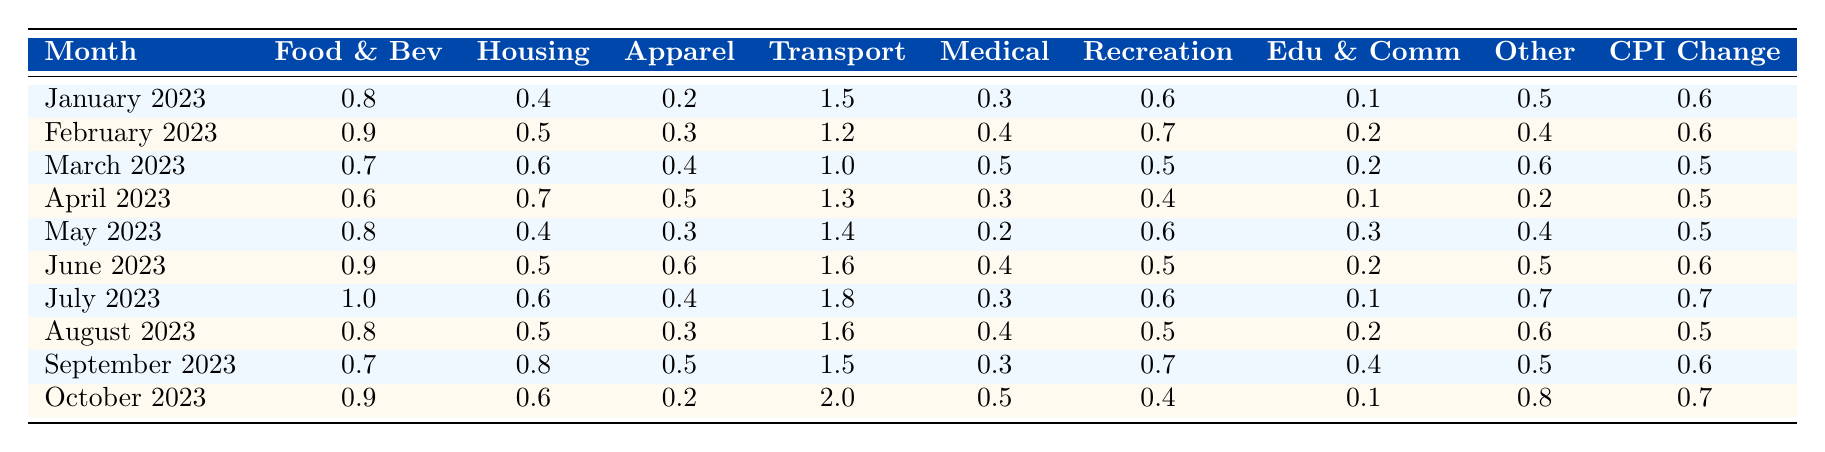What was the CPI change in July 2023? The table shows that the CPI Change for July 2023 is listed as 0.7.
Answer: 0.7 Which month had the highest value for Transportation? By checking the Transportation column, it is clear that October 2023 has the highest value at 2.0.
Answer: October 2023 What is the average increment of the Food and Beverages category over the year? To calculate the average, sum the Food and Beverages values: (0.8 + 0.9 + 0.7 + 0.6 + 0.8 + 0.9 + 1.0 + 0.8 + 0.7 + 0.9) = 8.1. There are 10 months, so the average is 8.1 / 10 = 0.81.
Answer: 0.81 In which month did Medical Care see the lowest value? The table indicates that the lowest value in the Medical Care column is 0.2, which occurs in May 2023.
Answer: May 2023 Was there a consistent increase in the Housing category throughout the year? By checking the Housing values month by month: 0.4, 0.5, 0.6, 0.7, 0.4, 0.5, 0.6, 0.5, 0.8, 0.6, it's evident that the values do not consistently increase and fluctuate instead.
Answer: No How much did the Other Goods and Services category change from January to October? The Other Goods and Services values are 0.5 in January 2023 and 0.8 in October 2023. The change is calculated as 0.8 - 0.5 = 0.3.
Answer: 0.3 Which component consistently had the lowest values over the observed months? By reviewing each category, Education and Communication has values of 0.1, 0.2, 0.2, 0.1, 0.3, 0.2, 0.1, indicating that it has maintained the lowest values consistently.
Answer: Education and Communication What was the total CPI Change for the months of June, July, and August combined? The CPI Changes for those months are 0.6 (June) + 0.7 (July) + 0.5 (August) = 1.8.
Answer: 1.8 Did the Medical Care category have an increase or decrease in October compared to the previous month? Looking at the values, Medical Care was 0.4 in September and increased to 0.5 in October, indicating an increase.
Answer: Increase Which month showed the least change in the CPI Change value compared to the previous month? The CPI Change values are: 0.6, 0.6, 0.5, 0.5, 0.5, 0.6, 0.7, 0.5, 0.6, 0.7. The least change can be seen from May to June (0.5 to 0.6) and from August to September (0.5 to 0.6), both with a change of 0.0 in between.
Answer: May to June and August to September What proportion of the highest increase in the Transportation category from one month to the next occurred between September and October? The values are 1.5 (September) and 2.0 (October), leading to an increase of 2.0 - 1.5 = 0.5. The previous highest value was in July at 1.8, indicating the increase is 0.5 on a base of 1.8. The proportion is therefore 0.5 / 1.8 = 0.277 or 27.7%.
Answer: 27.7% 